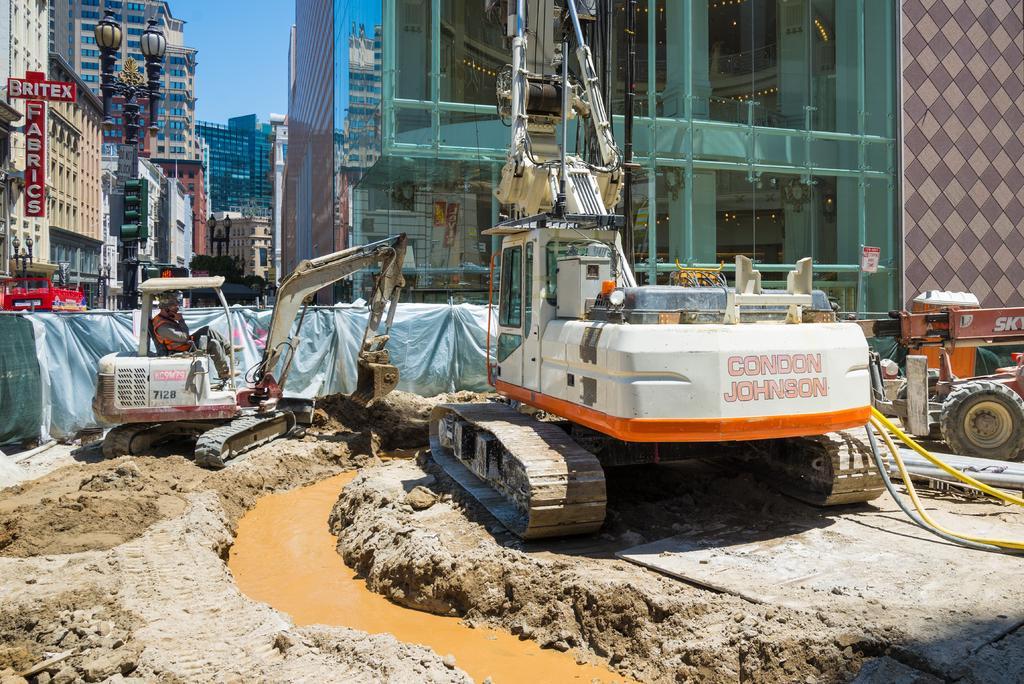Describe this image in one or two sentences. This picture is clicked outside. In the center we can see the group of vehicles. In the foreground we can see the mud and the water. In the background there is a sky and we can see the buildings and the lamps attached to the poles and some other objects and we can see the text on the boards. 